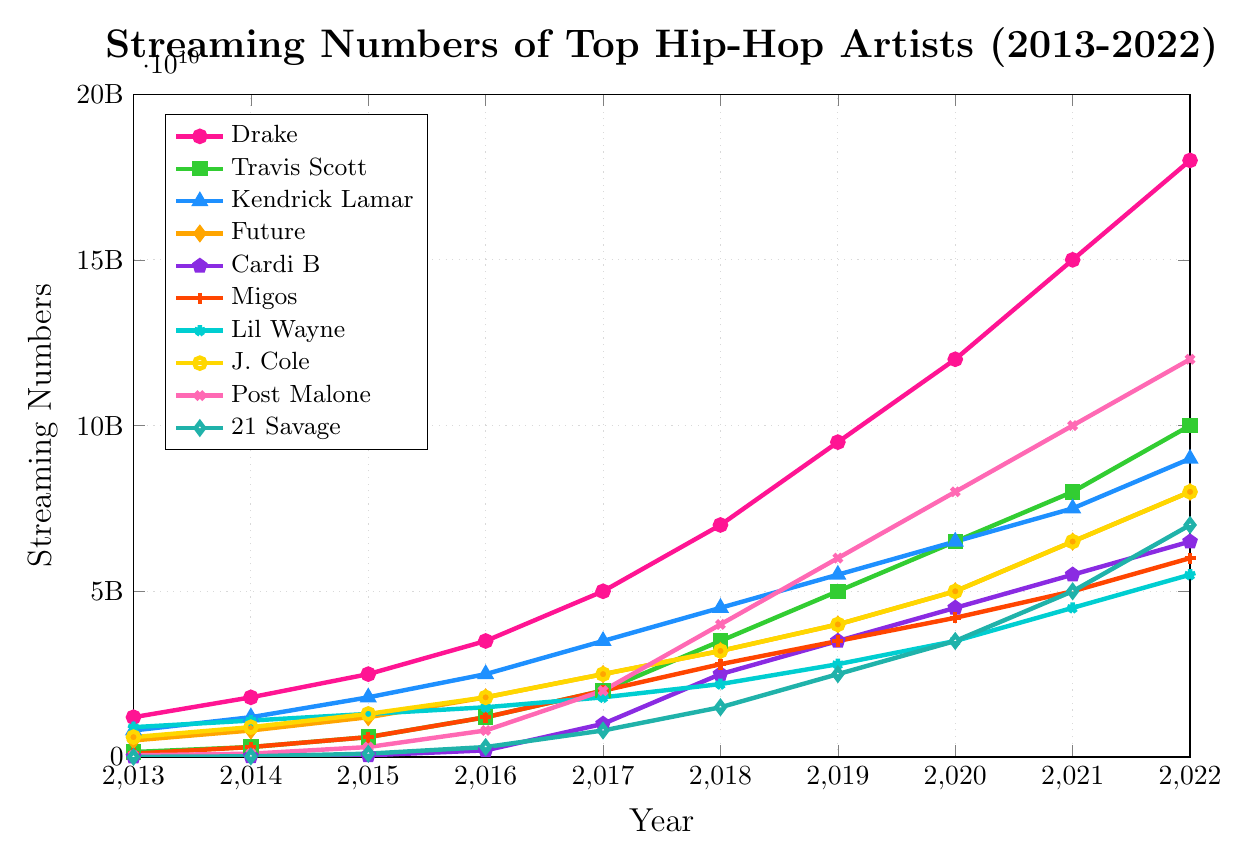What's the trend for Drake's streaming numbers between 2013 and 2022? Drake's streaming numbers increase every year without any decline, starting from 1.2 billion in 2013 and reaching 18 billion in 2022.
Answer: Increasing Which artist had the highest streaming numbers in 2022? In 2022, look at the highest points for each line. Post Malone's line is the highest with 12 billion streams.
Answer: Post Malone Compare Cardi B's and Kendrick Lamar's streaming numbers in 2018. Who had more streams? In 2018, Cardi B had 2.5 billion streams whereas Kendrick Lamar had 4.5 billion streams.
Answer: Kendrick Lamar What is the difference in streaming numbers between Future and Travis Scott in 2020? In 2020, Future had 5 billion streams and Travis Scott had 6.5 billion. The difference is 6.5 billion - 5 billion = 1.5 billion.
Answer: 1.5 billion Which artist showed the most significant growth between 2017 and 2018? Look at the steepest increase between 2017 and 2018. Travis Scott's streaming numbers increased from 2 billion to 3.5 billion, an increase of 1.5 billion.
Answer: Travis Scott What was the average number of streams for J. Cole between 2013 and 2022? Sum up J. Cole's streaming numbers from 2013 to 2022 and then divide by the number of years (10). The sum is (600M + 900M + 1300M + 1800M + 2500M + 3200M + 4000M + 5000M + 6500M + 8000M) = 32800M, so the average is 32800M / 10 = 3280M.
Answer: 3.28 billion Which year did Post Malone surpass 1 billion streams for the first time? Post Malone first surpasses 1 billion streams in the year where his line is above that level. This happens between 2016 and 2017.
Answer: 2017 Who had a higher increase in streaming numbers from 2019 to 2022, Lil Wayne or 21 Savage? Lil Wayne's increase is from 2.8 billion to 5.5 billion (a 2.7 billion increase), while 21 Savage's increase is from 2.5 billion to 7 billion (a 4.5 billion increase).
Answer: 21 Savage 